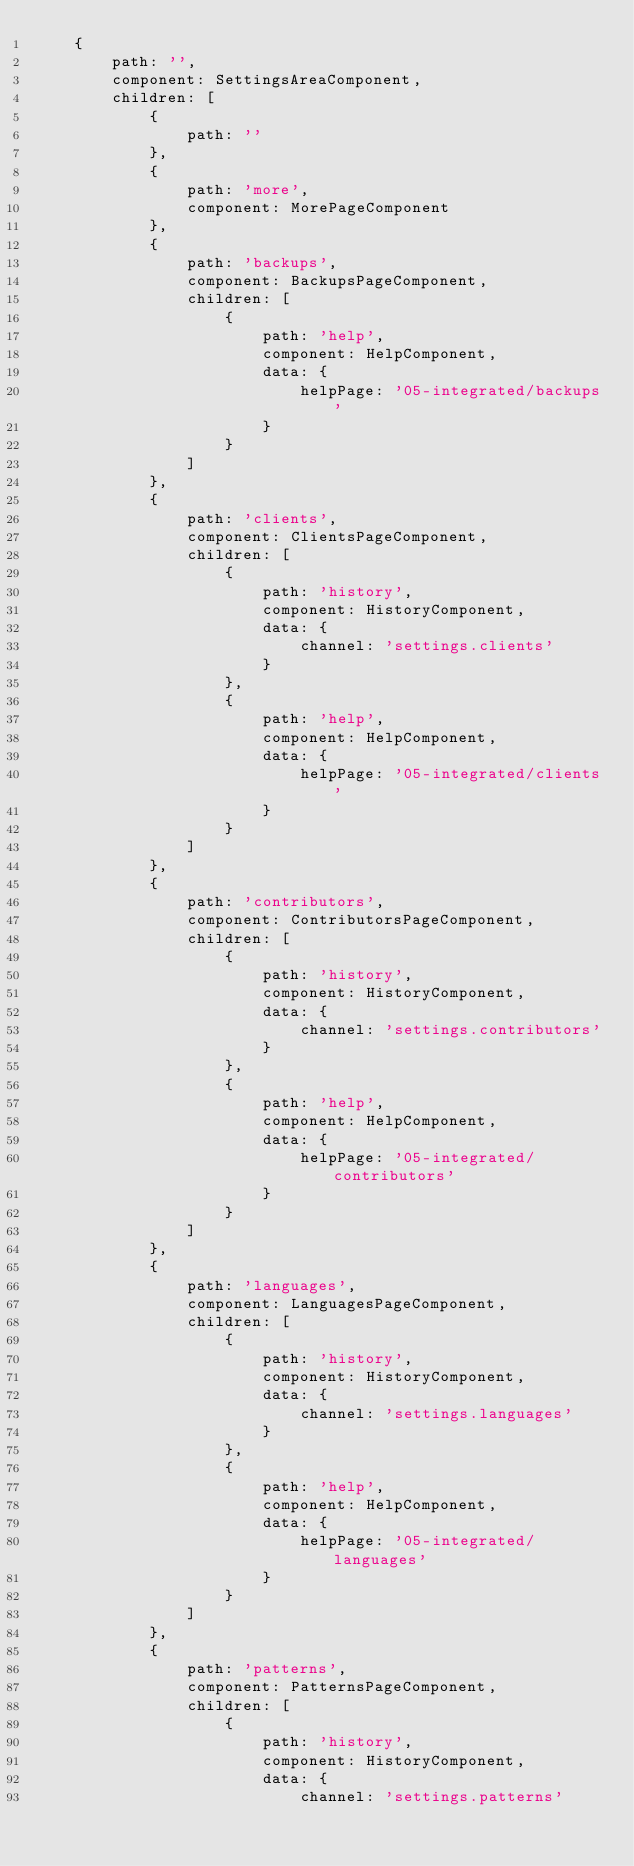<code> <loc_0><loc_0><loc_500><loc_500><_TypeScript_>    {
        path: '',
        component: SettingsAreaComponent,
        children: [
            {
                path: ''
            },
            {
                path: 'more',
                component: MorePageComponent
            },
            {
                path: 'backups',
                component: BackupsPageComponent,
                children: [
                    {
                        path: 'help',
                        component: HelpComponent,
                        data: {
                            helpPage: '05-integrated/backups'
                        }
                    }
                ]
            },
            {
                path: 'clients',
                component: ClientsPageComponent,
                children: [
                    {
                        path: 'history',
                        component: HistoryComponent,
                        data: {
                            channel: 'settings.clients'
                        }
                    },
                    {
                        path: 'help',
                        component: HelpComponent,
                        data: {
                            helpPage: '05-integrated/clients'
                        }
                    }
                ]
            },
            {
                path: 'contributors',
                component: ContributorsPageComponent,
                children: [
                    {
                        path: 'history',
                        component: HistoryComponent,
                        data: {
                            channel: 'settings.contributors'
                        }
                    },
                    {
                        path: 'help',
                        component: HelpComponent,
                        data: {
                            helpPage: '05-integrated/contributors'
                        }
                    }
                ]
            },
            {
                path: 'languages',
                component: LanguagesPageComponent,
                children: [
                    {
                        path: 'history',
                        component: HistoryComponent,
                        data: {
                            channel: 'settings.languages'
                        }
                    },
                    {
                        path: 'help',
                        component: HelpComponent,
                        data: {
                            helpPage: '05-integrated/languages'
                        }
                    }
                ]
            },
            {
                path: 'patterns',
                component: PatternsPageComponent,
                children: [
                    {
                        path: 'history',
                        component: HistoryComponent,
                        data: {
                            channel: 'settings.patterns'</code> 